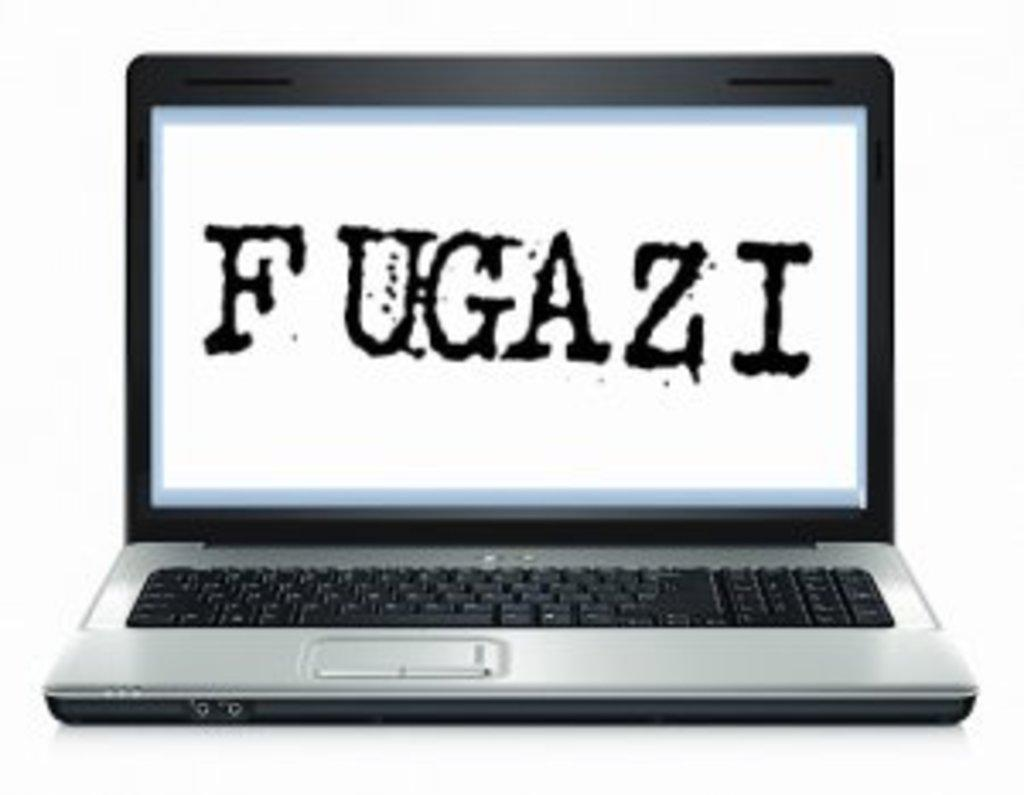<image>
Provide a brief description of the given image. Silver laptop with a screen that says F Ugazi. 